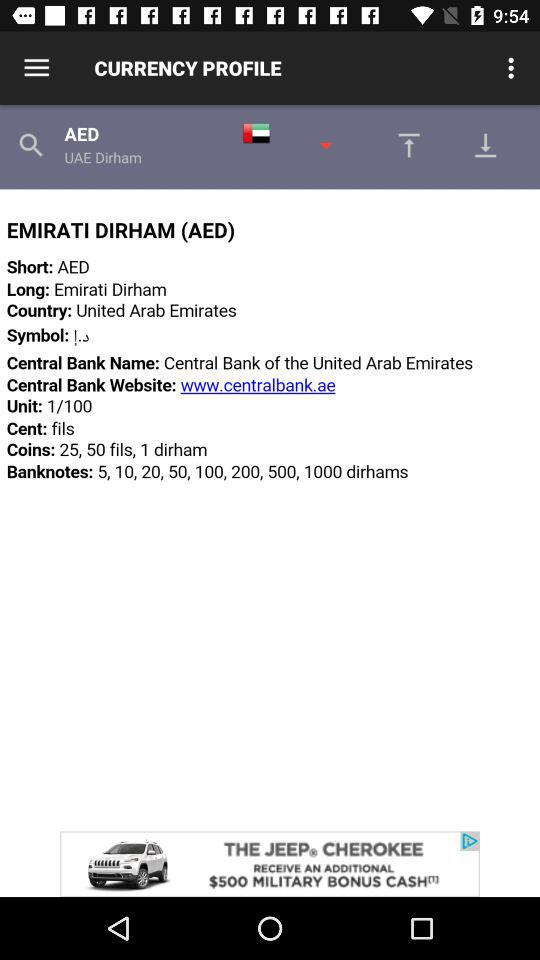How many units are there? There is 1 unit. 